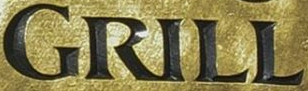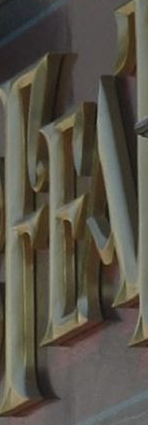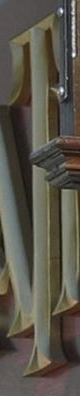Read the text from these images in sequence, separated by a semicolon. GRILL; FEA; T 